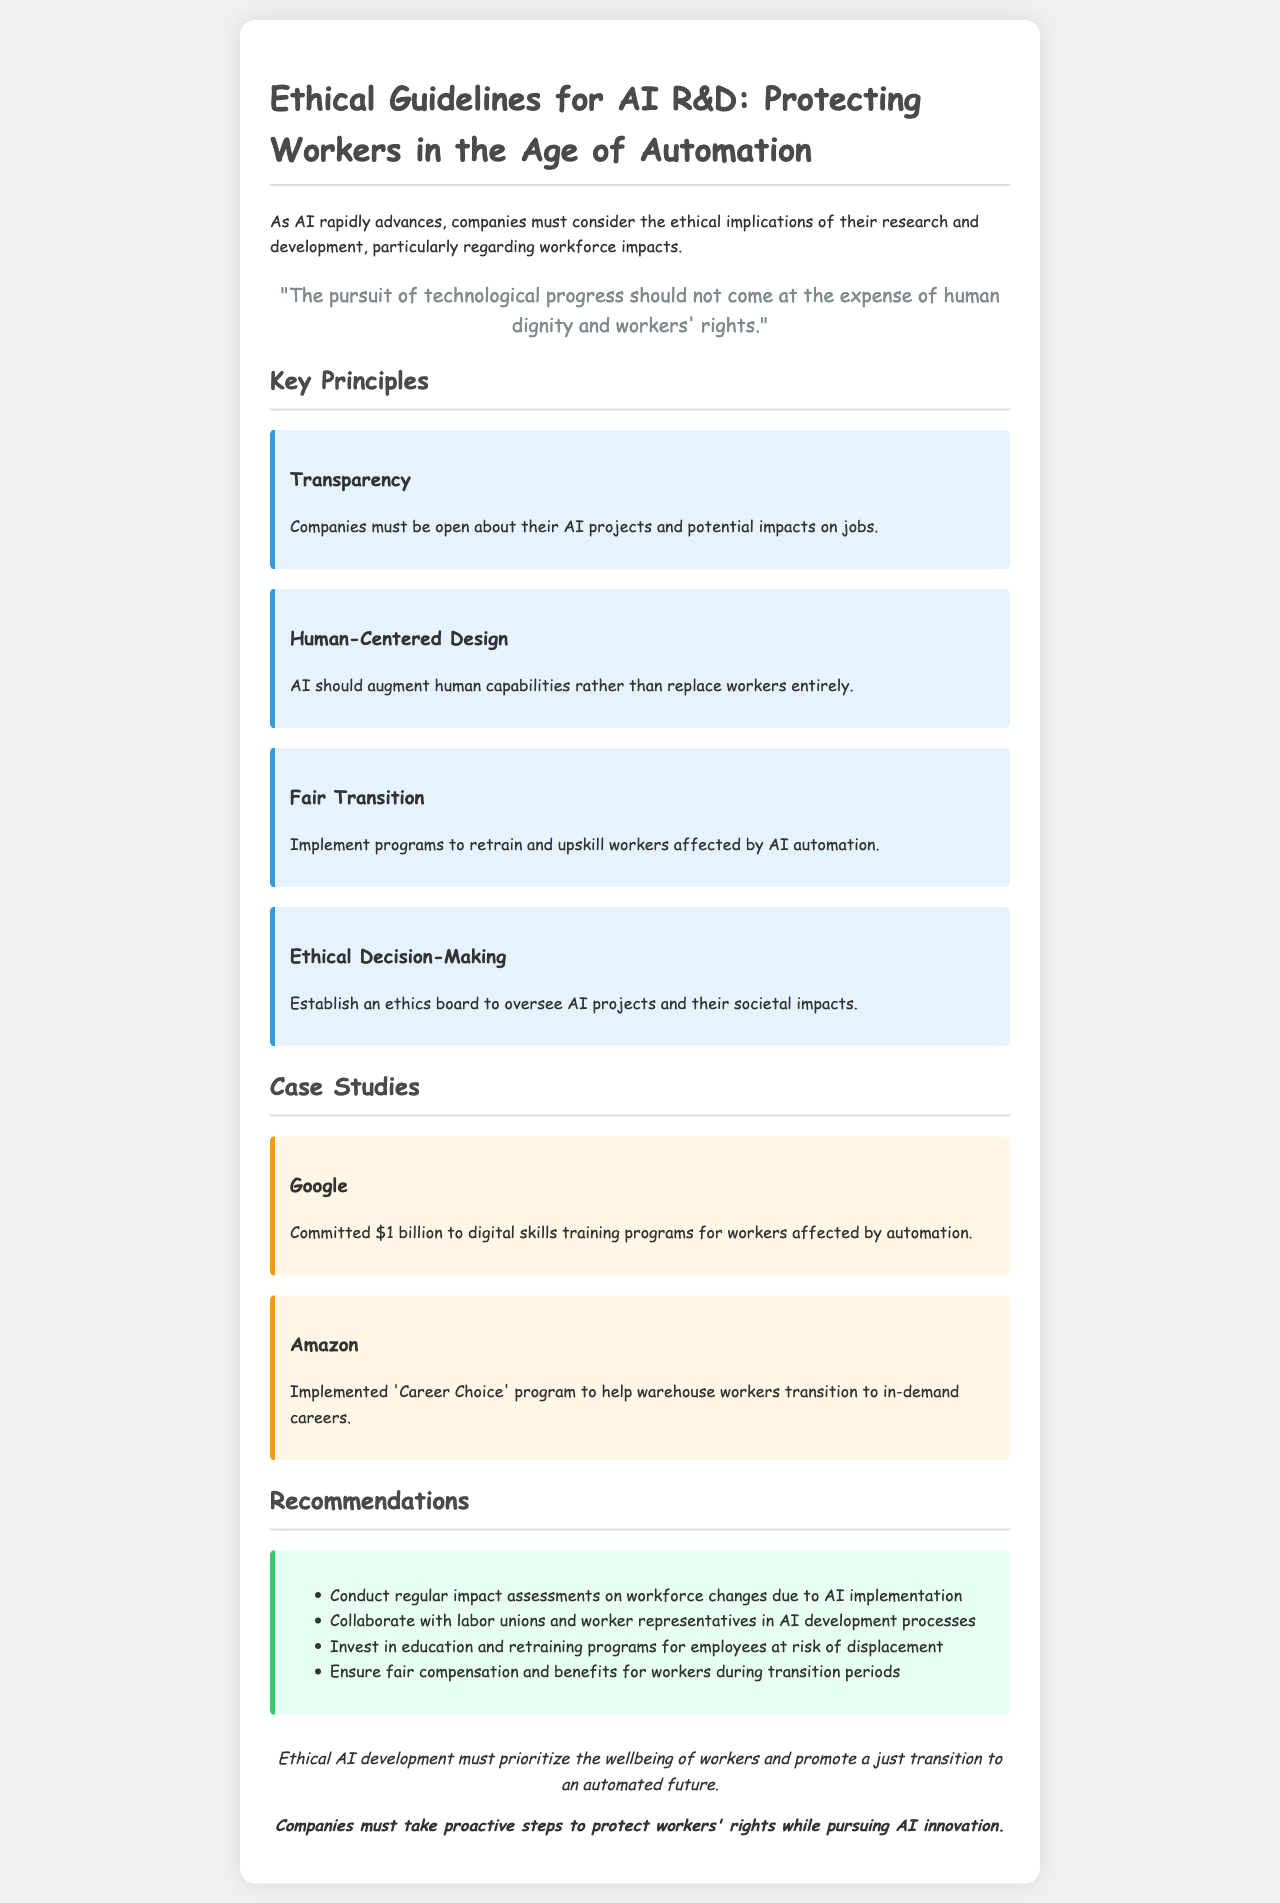What is the title of the document? The title of the document is presented in the header section.
Answer: Ethical Guidelines for AI R&D: Protecting Workers What principle emphasizes the need for transparency? The principle is specifically highlighted under the "Key Principles" section with a distinct header.
Answer: Transparency How much did Google commit to digital skills training? This amount is stated in the Google case study.
Answer: $1 billion What program did Amazon implement to help workers? This program is mentioned in the Amazon case study.
Answer: Career Choice What is one of the recommendations for AI implementation? The recommendation is listed under the "Recommendations" section.
Answer: Conduct regular impact assessments on workforce changes due to AI implementation Which principle focuses on retraining impacted workers? This principle is outlined clearly in the "Key Principles" section.
Answer: Fair Transition What is the key goal of ethical AI development according to the conclusion? The goal is emphasized in the last part of the document.
Answer: Prioritize the wellbeing of workers What type of board should companies establish for AI projects? This type of board is mentioned under the "Ethical Decision-Making" principle.
Answer: Ethics board 